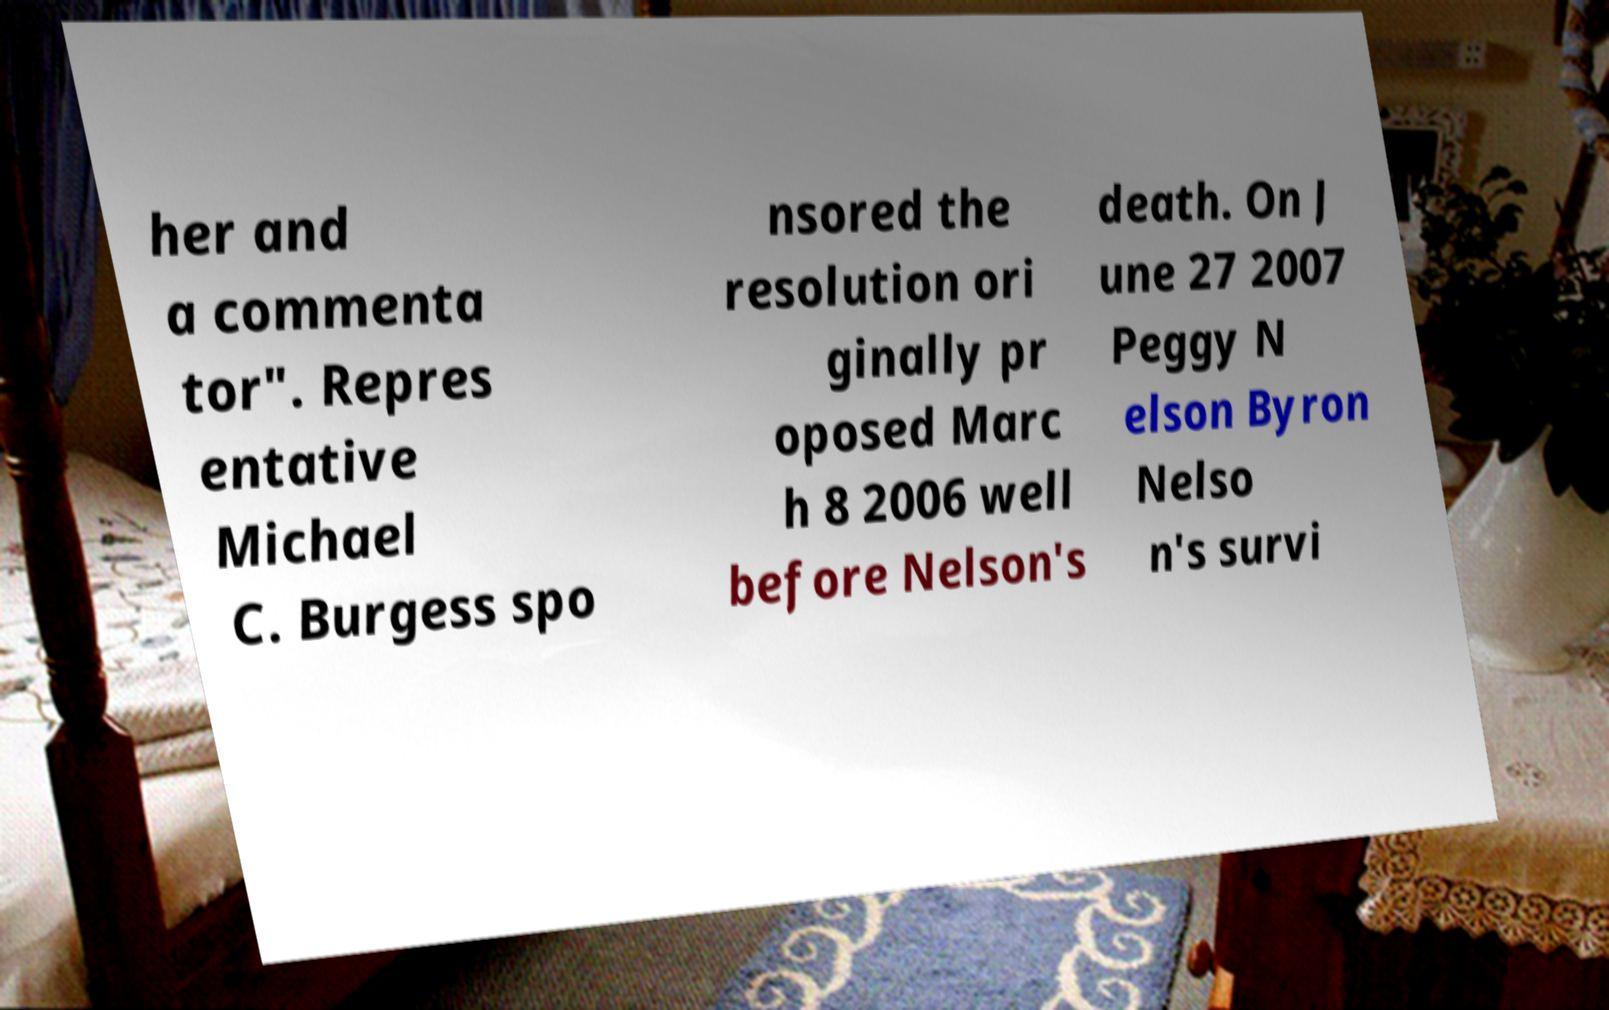Could you extract and type out the text from this image? her and a commenta tor". Repres entative Michael C. Burgess spo nsored the resolution ori ginally pr oposed Marc h 8 2006 well before Nelson's death. On J une 27 2007 Peggy N elson Byron Nelso n's survi 